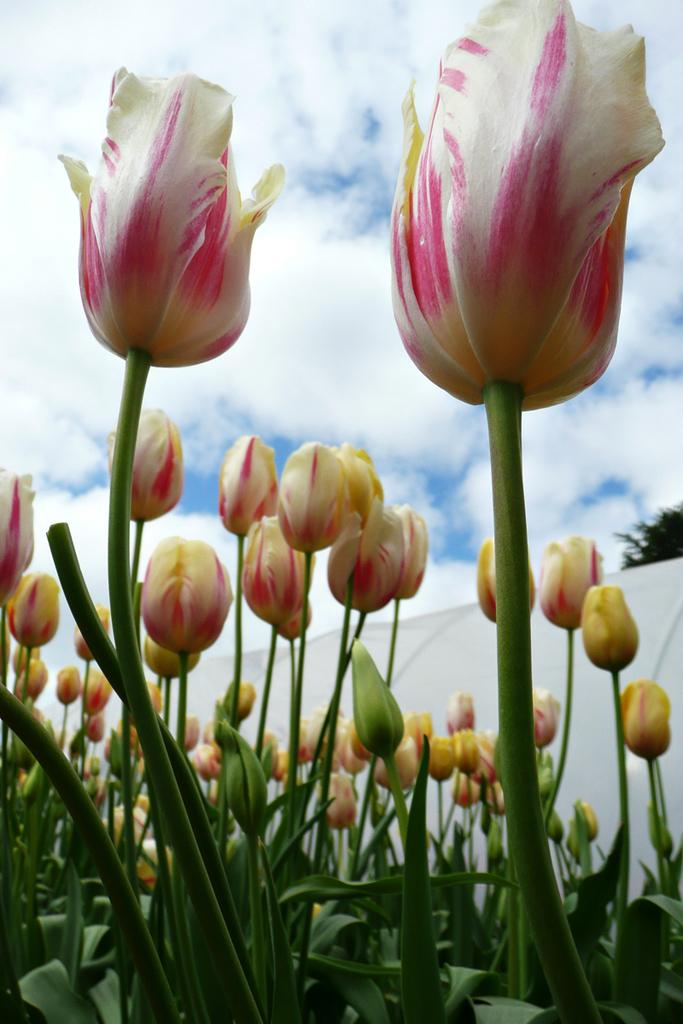What types of plant elements are visible in the image? There are buds and leaves in the image. What can be seen in the sky in the image? There are clouds in the sky. What object is located in the middle of the image? There is a cloth in the middle of the image. What type of drug is being sold at the attraction in the image? There is no drug or attraction present in the image; it features buds, leaves, and clouds. 